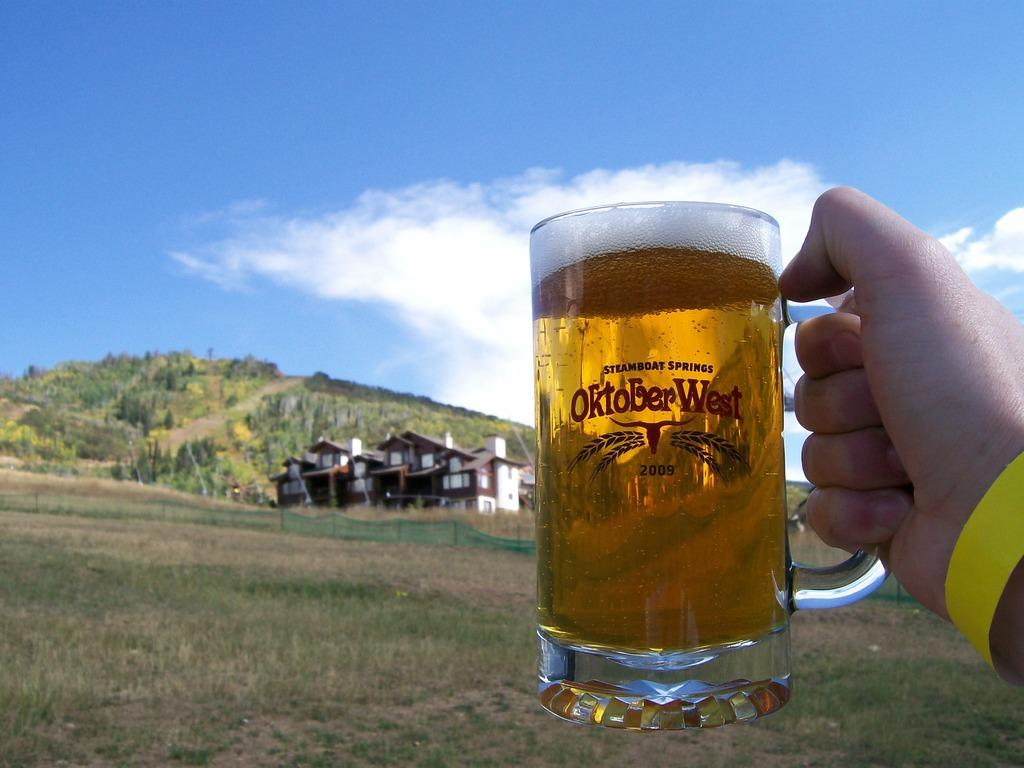<image>
Present a compact description of the photo's key features. A hand holding up a beer mug labeled Oktober West 